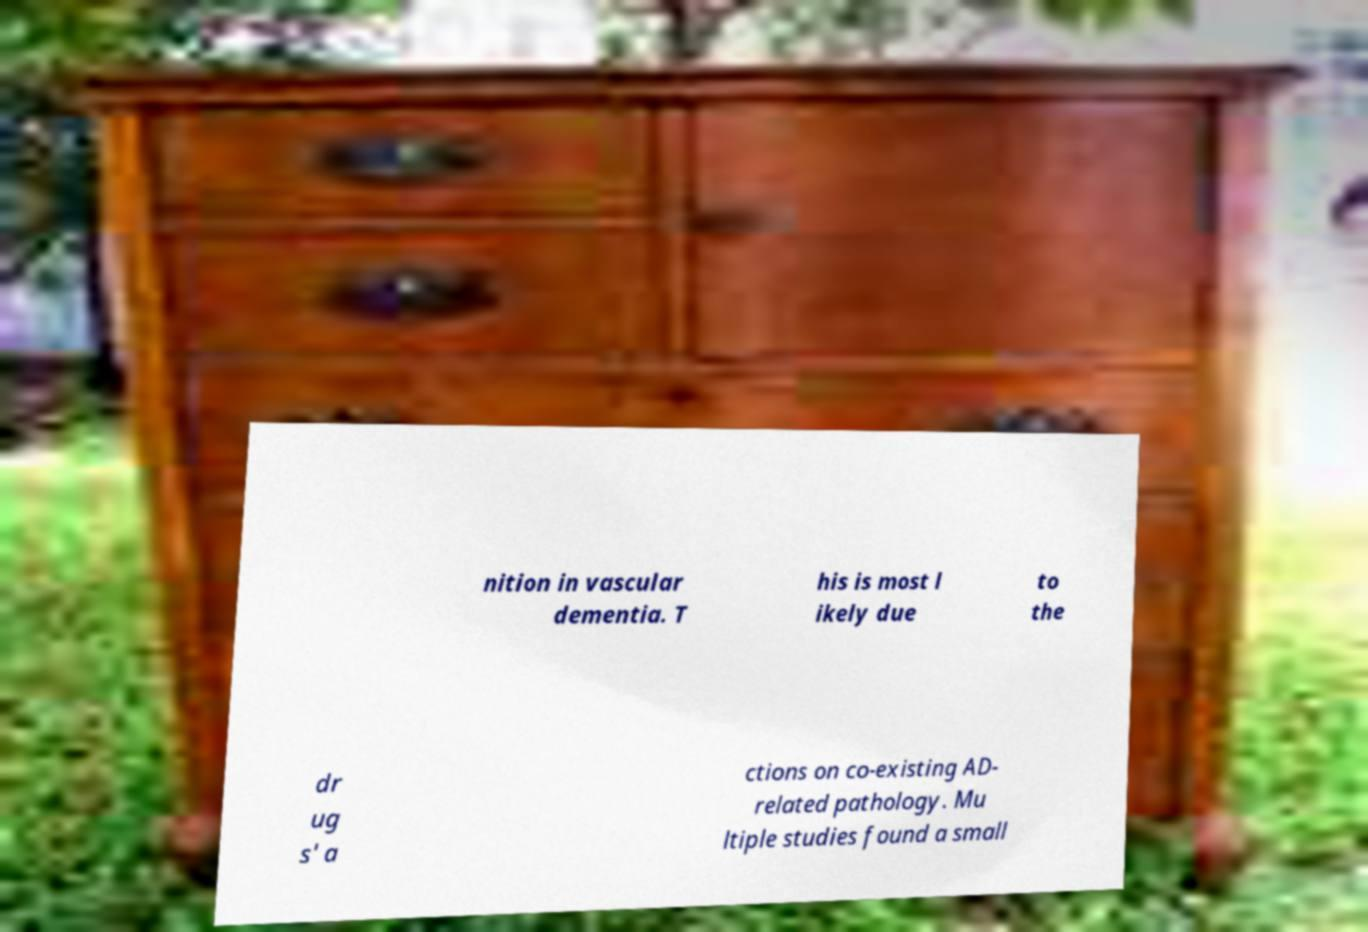Could you extract and type out the text from this image? nition in vascular dementia. T his is most l ikely due to the dr ug s' a ctions on co-existing AD- related pathology. Mu ltiple studies found a small 